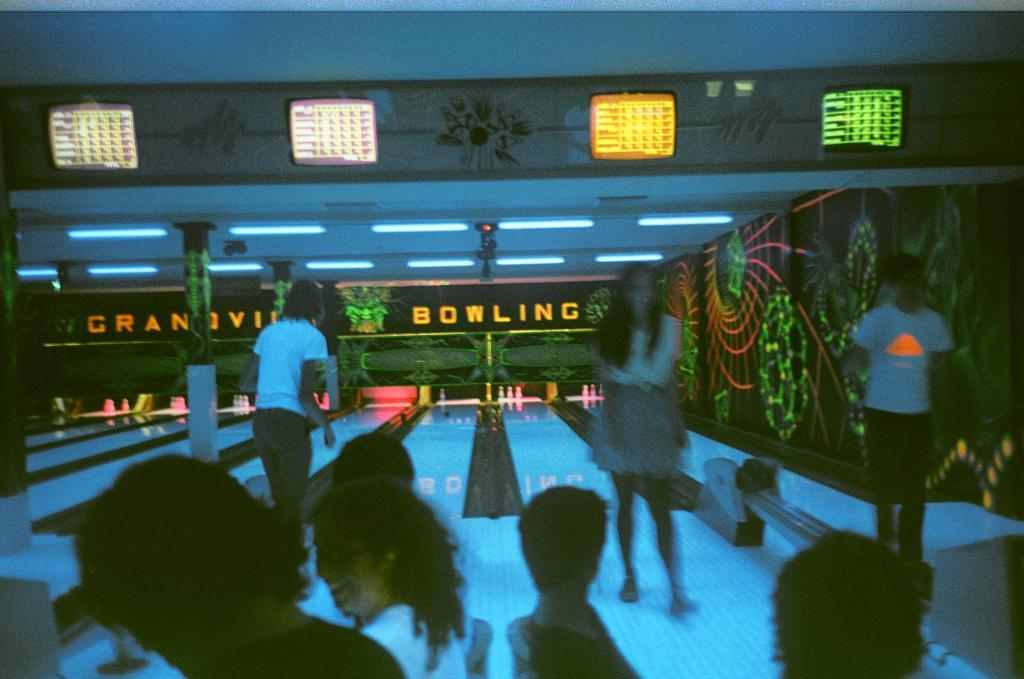What is the main subject of the image? The main subject of the image is a group of people. What can be seen in the background of the image? In the background of the image, there are pins and lights visible. What type of sea creatures can be seen swimming in the image? There is no sea or sea creatures present in the image; it features a group of people and background elements. 